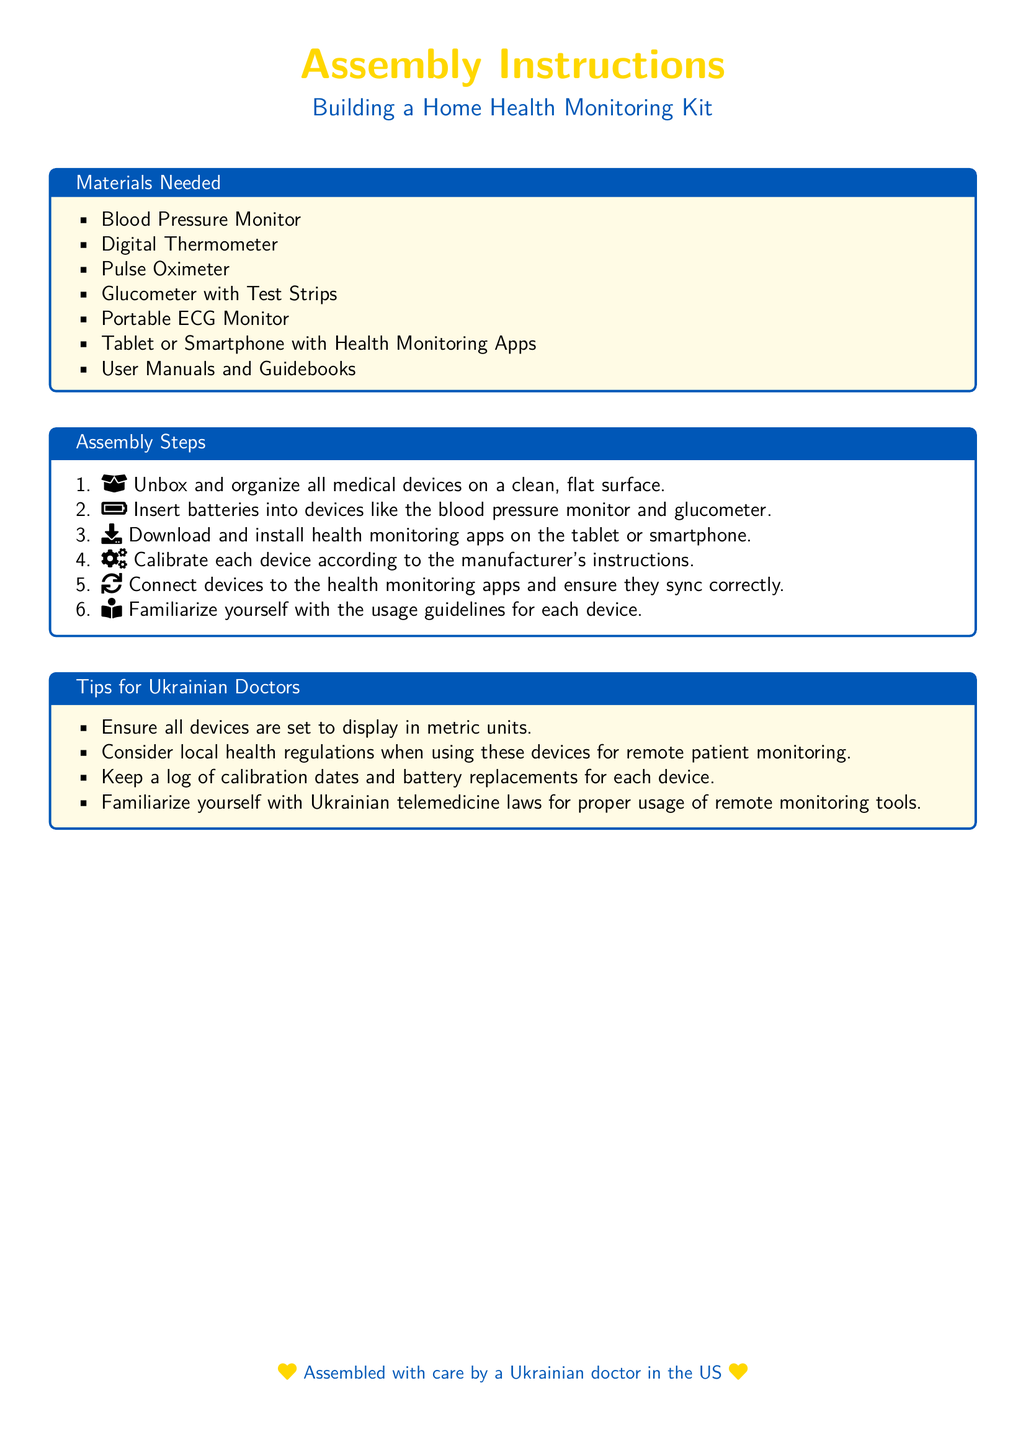What is the title of the document? The title of the document is located in the center and is presented prominently.
Answer: Building a Home Health Monitoring Kit How many materials are listed in the document? The number of materials in the "Materials Needed" section can be counted.
Answer: Seven What is the first step in the assembly instructions? The first step is mentioned in the "Assembly Steps" section, outlining the initial action to take.
Answer: Unbox and organize all medical devices on a clean, flat surface What type of thermometer is included in the materials needed? The type of thermometer is specifically mentioned in the list of needed materials.
Answer: Digital Thermometer What battery-related action is included in the assembly steps? The document specifies an action regarding batteries in one of the steps.
Answer: Insert batteries into devices Which professional perspective is emphasized in the tips section? The tips section explicitly mentions a target audience for the advice provided.
Answer: Ukrainian Doctors What color is used for the background of the title? The background color for the title is described in the document's color scheme.
Answer: Yellow How many tips are provided for Ukrainian doctors? The number of tips can be counted in the "Tips for Ukrainian Doctors" section.
Answer: Four 